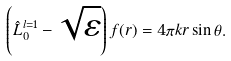Convert formula to latex. <formula><loc_0><loc_0><loc_500><loc_500>\left ( \hat { L } _ { 0 } ^ { l = 1 } - \sqrt { \varepsilon } \right ) f ( r ) = 4 \pi k r \sin \theta .</formula> 